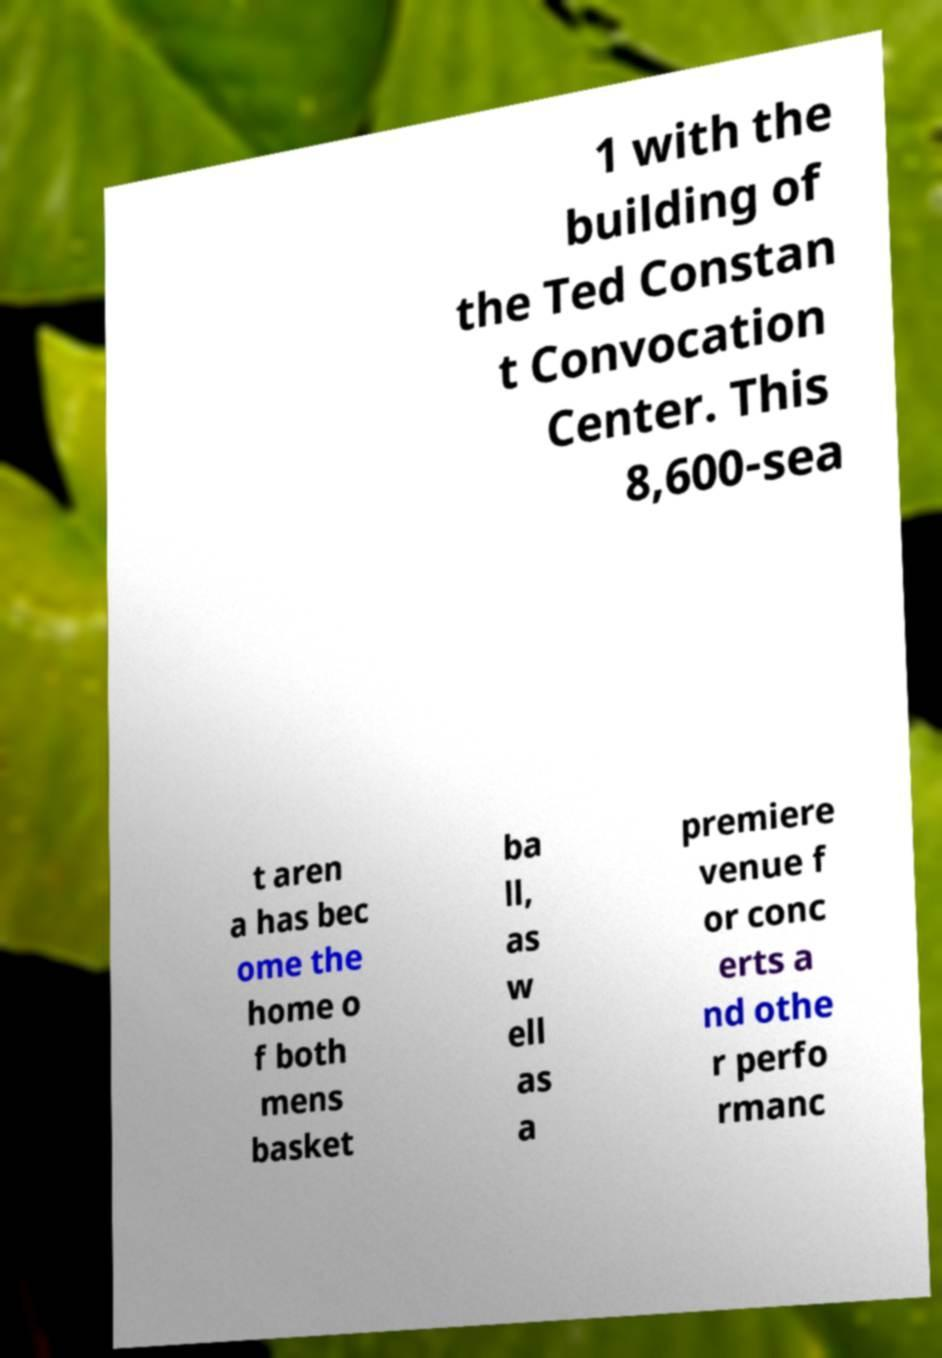Can you accurately transcribe the text from the provided image for me? 1 with the building of the Ted Constan t Convocation Center. This 8,600-sea t aren a has bec ome the home o f both mens basket ba ll, as w ell as a premiere venue f or conc erts a nd othe r perfo rmanc 